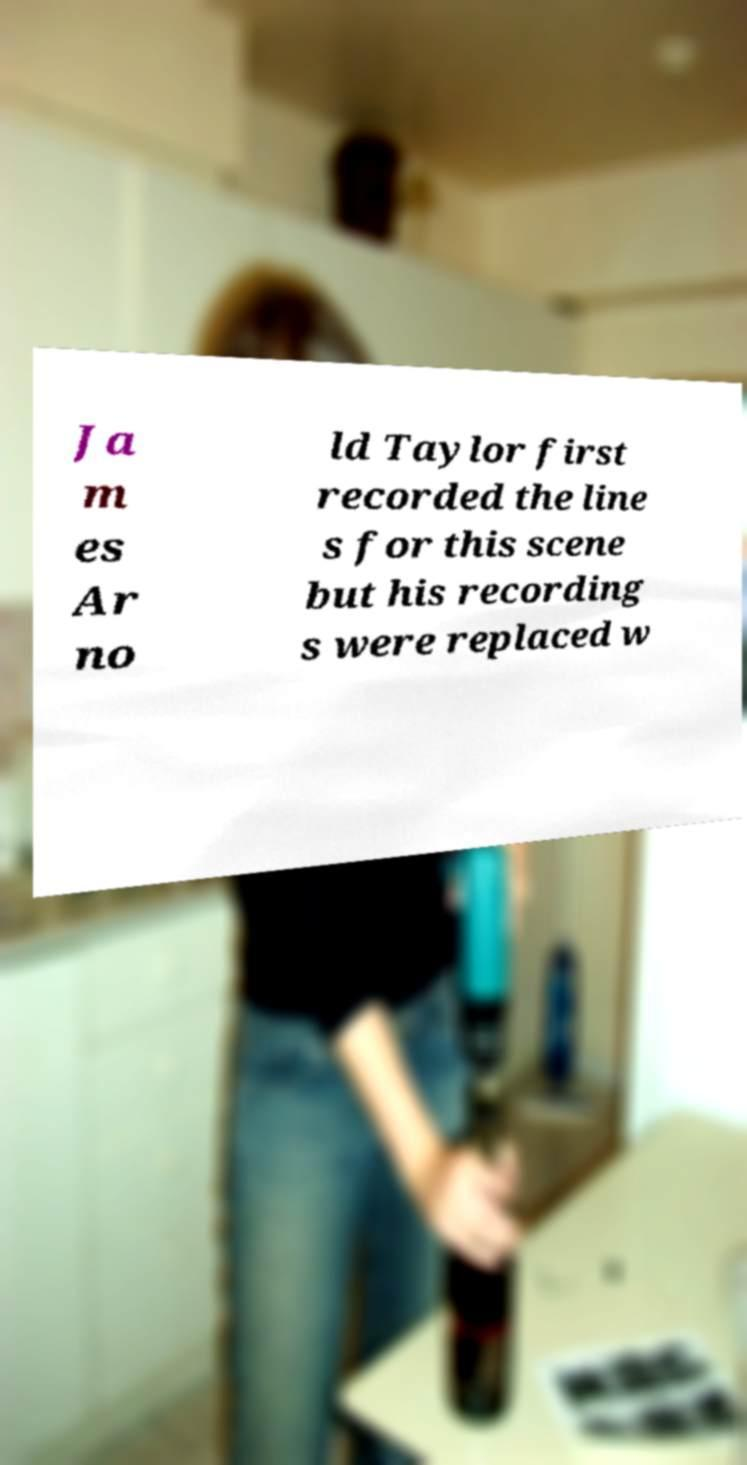Can you accurately transcribe the text from the provided image for me? Ja m es Ar no ld Taylor first recorded the line s for this scene but his recording s were replaced w 